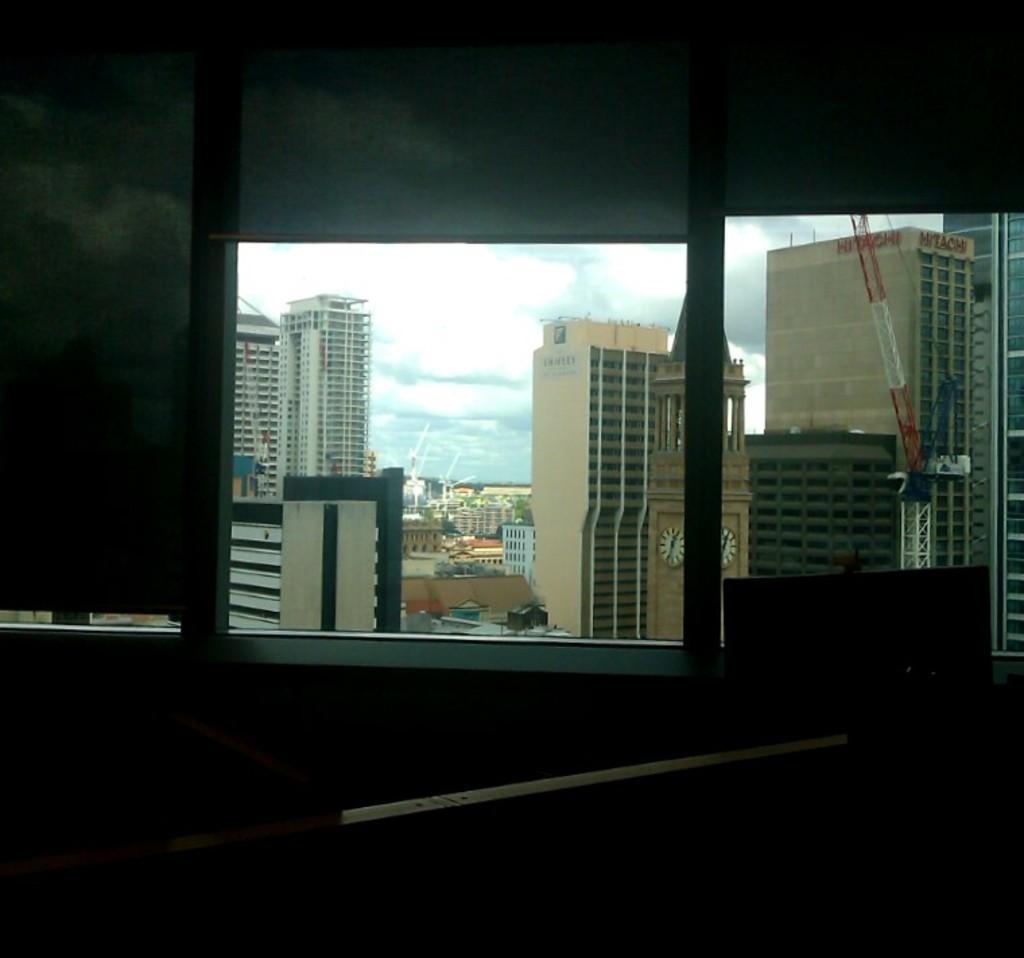How would you summarize this image in a sentence or two? In this image I can see few windows, background I can see few buildings in white, cream and brown color, trees in green color and the sky is in blue and white color. 